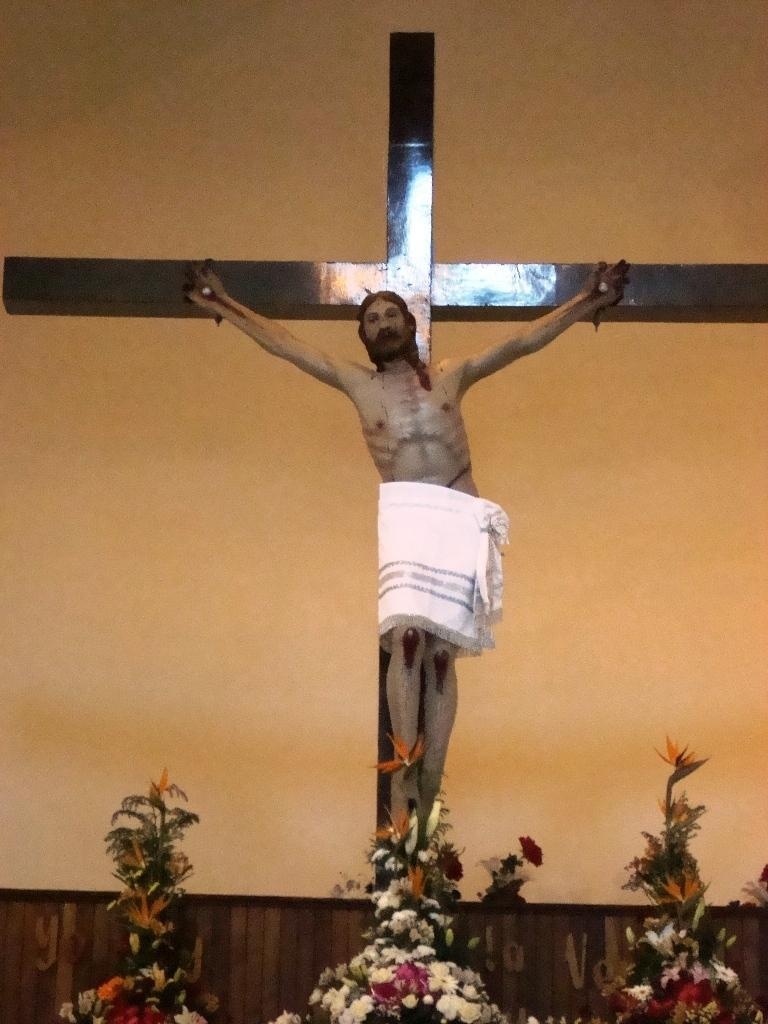What is depicted on the sign in the image? There is a sculpture of a man on a sign in the image. What type of flora can be seen in the image? There are colorful flowers in the image. What color is the wall in the image? The wall in the image is orange in color. What type of animals can be seen in the zoo in the image? There is no zoo present in the image; it features a sculpture of a man on a sign, colorful flowers, and an orange wall. What type of medical care is provided at the hospital in the image? There is no hospital present in the image; it features a sculpture of a man on a sign, colorful flowers, and an orange wall. 